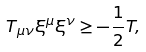<formula> <loc_0><loc_0><loc_500><loc_500>T _ { \mu \nu } \xi ^ { \mu } \xi ^ { \nu } \geq - \frac { 1 } { 2 } T ,</formula> 